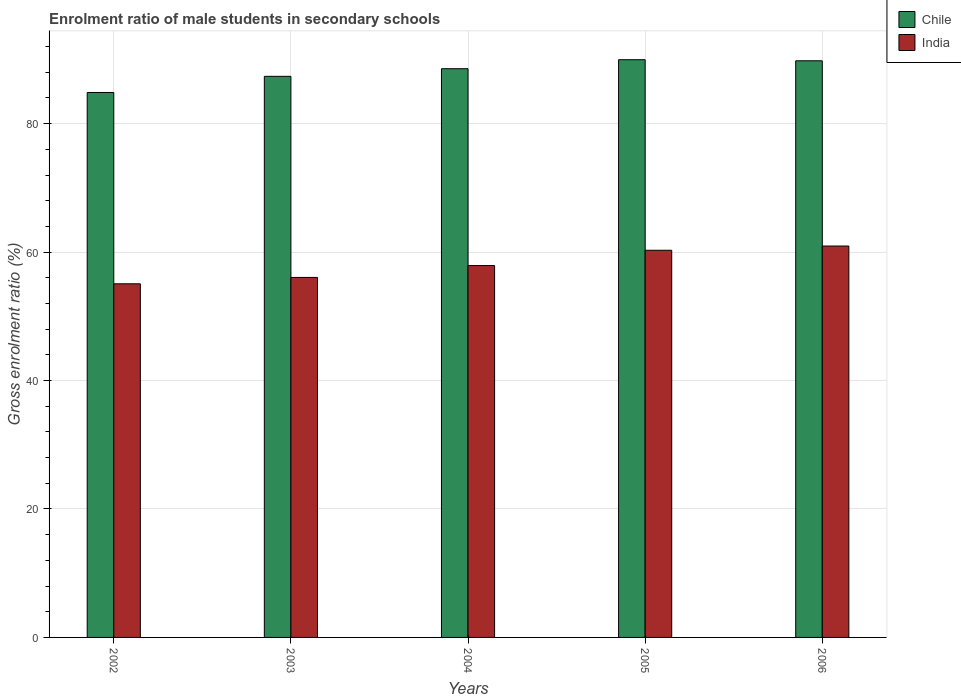How many different coloured bars are there?
Provide a succinct answer. 2. Are the number of bars on each tick of the X-axis equal?
Provide a succinct answer. Yes. How many bars are there on the 5th tick from the right?
Provide a short and direct response. 2. What is the label of the 1st group of bars from the left?
Your answer should be very brief. 2002. In how many cases, is the number of bars for a given year not equal to the number of legend labels?
Your answer should be very brief. 0. What is the enrolment ratio of male students in secondary schools in India in 2002?
Your answer should be very brief. 55.06. Across all years, what is the maximum enrolment ratio of male students in secondary schools in Chile?
Give a very brief answer. 89.95. Across all years, what is the minimum enrolment ratio of male students in secondary schools in India?
Your response must be concise. 55.06. What is the total enrolment ratio of male students in secondary schools in Chile in the graph?
Provide a short and direct response. 440.51. What is the difference between the enrolment ratio of male students in secondary schools in India in 2002 and that in 2003?
Your response must be concise. -0.99. What is the difference between the enrolment ratio of male students in secondary schools in Chile in 2003 and the enrolment ratio of male students in secondary schools in India in 2002?
Offer a terse response. 32.3. What is the average enrolment ratio of male students in secondary schools in Chile per year?
Ensure brevity in your answer.  88.1. In the year 2006, what is the difference between the enrolment ratio of male students in secondary schools in Chile and enrolment ratio of male students in secondary schools in India?
Make the answer very short. 28.84. In how many years, is the enrolment ratio of male students in secondary schools in India greater than 12 %?
Provide a succinct answer. 5. What is the ratio of the enrolment ratio of male students in secondary schools in India in 2003 to that in 2005?
Offer a very short reply. 0.93. Is the enrolment ratio of male students in secondary schools in Chile in 2002 less than that in 2003?
Keep it short and to the point. Yes. What is the difference between the highest and the second highest enrolment ratio of male students in secondary schools in Chile?
Make the answer very short. 0.17. What is the difference between the highest and the lowest enrolment ratio of male students in secondary schools in Chile?
Give a very brief answer. 5.1. In how many years, is the enrolment ratio of male students in secondary schools in India greater than the average enrolment ratio of male students in secondary schools in India taken over all years?
Offer a very short reply. 2. What does the 2nd bar from the right in 2002 represents?
Your response must be concise. Chile. What is the difference between two consecutive major ticks on the Y-axis?
Provide a succinct answer. 20. Does the graph contain any zero values?
Your response must be concise. No. Where does the legend appear in the graph?
Make the answer very short. Top right. How many legend labels are there?
Give a very brief answer. 2. How are the legend labels stacked?
Your answer should be very brief. Vertical. What is the title of the graph?
Your response must be concise. Enrolment ratio of male students in secondary schools. What is the label or title of the Y-axis?
Make the answer very short. Gross enrolment ratio (%). What is the Gross enrolment ratio (%) in Chile in 2002?
Offer a very short reply. 84.85. What is the Gross enrolment ratio (%) in India in 2002?
Provide a short and direct response. 55.06. What is the Gross enrolment ratio (%) of Chile in 2003?
Keep it short and to the point. 87.36. What is the Gross enrolment ratio (%) of India in 2003?
Your answer should be very brief. 56.05. What is the Gross enrolment ratio (%) of Chile in 2004?
Offer a very short reply. 88.55. What is the Gross enrolment ratio (%) in India in 2004?
Give a very brief answer. 57.9. What is the Gross enrolment ratio (%) of Chile in 2005?
Provide a short and direct response. 89.95. What is the Gross enrolment ratio (%) of India in 2005?
Your answer should be very brief. 60.28. What is the Gross enrolment ratio (%) of Chile in 2006?
Give a very brief answer. 89.79. What is the Gross enrolment ratio (%) in India in 2006?
Provide a short and direct response. 60.94. Across all years, what is the maximum Gross enrolment ratio (%) of Chile?
Your answer should be compact. 89.95. Across all years, what is the maximum Gross enrolment ratio (%) of India?
Provide a succinct answer. 60.94. Across all years, what is the minimum Gross enrolment ratio (%) of Chile?
Your answer should be very brief. 84.85. Across all years, what is the minimum Gross enrolment ratio (%) in India?
Ensure brevity in your answer.  55.06. What is the total Gross enrolment ratio (%) in Chile in the graph?
Your answer should be very brief. 440.51. What is the total Gross enrolment ratio (%) in India in the graph?
Make the answer very short. 290.24. What is the difference between the Gross enrolment ratio (%) of Chile in 2002 and that in 2003?
Make the answer very short. -2.51. What is the difference between the Gross enrolment ratio (%) in India in 2002 and that in 2003?
Provide a short and direct response. -0.99. What is the difference between the Gross enrolment ratio (%) of Chile in 2002 and that in 2004?
Provide a succinct answer. -3.7. What is the difference between the Gross enrolment ratio (%) of India in 2002 and that in 2004?
Your response must be concise. -2.84. What is the difference between the Gross enrolment ratio (%) of Chile in 2002 and that in 2005?
Provide a short and direct response. -5.1. What is the difference between the Gross enrolment ratio (%) of India in 2002 and that in 2005?
Make the answer very short. -5.22. What is the difference between the Gross enrolment ratio (%) in Chile in 2002 and that in 2006?
Offer a very short reply. -4.93. What is the difference between the Gross enrolment ratio (%) in India in 2002 and that in 2006?
Provide a short and direct response. -5.88. What is the difference between the Gross enrolment ratio (%) of Chile in 2003 and that in 2004?
Your response must be concise. -1.19. What is the difference between the Gross enrolment ratio (%) of India in 2003 and that in 2004?
Your answer should be compact. -1.85. What is the difference between the Gross enrolment ratio (%) in Chile in 2003 and that in 2005?
Ensure brevity in your answer.  -2.59. What is the difference between the Gross enrolment ratio (%) of India in 2003 and that in 2005?
Provide a succinct answer. -4.23. What is the difference between the Gross enrolment ratio (%) in Chile in 2003 and that in 2006?
Your answer should be very brief. -2.42. What is the difference between the Gross enrolment ratio (%) of India in 2003 and that in 2006?
Ensure brevity in your answer.  -4.89. What is the difference between the Gross enrolment ratio (%) in Chile in 2004 and that in 2005?
Keep it short and to the point. -1.4. What is the difference between the Gross enrolment ratio (%) of India in 2004 and that in 2005?
Give a very brief answer. -2.38. What is the difference between the Gross enrolment ratio (%) of Chile in 2004 and that in 2006?
Give a very brief answer. -1.23. What is the difference between the Gross enrolment ratio (%) of India in 2004 and that in 2006?
Ensure brevity in your answer.  -3.04. What is the difference between the Gross enrolment ratio (%) in Chile in 2005 and that in 2006?
Your answer should be compact. 0.17. What is the difference between the Gross enrolment ratio (%) in India in 2005 and that in 2006?
Give a very brief answer. -0.66. What is the difference between the Gross enrolment ratio (%) in Chile in 2002 and the Gross enrolment ratio (%) in India in 2003?
Your answer should be compact. 28.8. What is the difference between the Gross enrolment ratio (%) in Chile in 2002 and the Gross enrolment ratio (%) in India in 2004?
Provide a succinct answer. 26.95. What is the difference between the Gross enrolment ratio (%) of Chile in 2002 and the Gross enrolment ratio (%) of India in 2005?
Your response must be concise. 24.57. What is the difference between the Gross enrolment ratio (%) of Chile in 2002 and the Gross enrolment ratio (%) of India in 2006?
Offer a terse response. 23.91. What is the difference between the Gross enrolment ratio (%) in Chile in 2003 and the Gross enrolment ratio (%) in India in 2004?
Offer a very short reply. 29.46. What is the difference between the Gross enrolment ratio (%) in Chile in 2003 and the Gross enrolment ratio (%) in India in 2005?
Ensure brevity in your answer.  27.08. What is the difference between the Gross enrolment ratio (%) in Chile in 2003 and the Gross enrolment ratio (%) in India in 2006?
Provide a succinct answer. 26.42. What is the difference between the Gross enrolment ratio (%) of Chile in 2004 and the Gross enrolment ratio (%) of India in 2005?
Your response must be concise. 28.27. What is the difference between the Gross enrolment ratio (%) in Chile in 2004 and the Gross enrolment ratio (%) in India in 2006?
Your answer should be very brief. 27.61. What is the difference between the Gross enrolment ratio (%) of Chile in 2005 and the Gross enrolment ratio (%) of India in 2006?
Your answer should be very brief. 29.01. What is the average Gross enrolment ratio (%) of Chile per year?
Provide a short and direct response. 88.1. What is the average Gross enrolment ratio (%) in India per year?
Provide a succinct answer. 58.05. In the year 2002, what is the difference between the Gross enrolment ratio (%) of Chile and Gross enrolment ratio (%) of India?
Provide a succinct answer. 29.79. In the year 2003, what is the difference between the Gross enrolment ratio (%) in Chile and Gross enrolment ratio (%) in India?
Offer a terse response. 31.31. In the year 2004, what is the difference between the Gross enrolment ratio (%) in Chile and Gross enrolment ratio (%) in India?
Your response must be concise. 30.65. In the year 2005, what is the difference between the Gross enrolment ratio (%) of Chile and Gross enrolment ratio (%) of India?
Ensure brevity in your answer.  29.67. In the year 2006, what is the difference between the Gross enrolment ratio (%) of Chile and Gross enrolment ratio (%) of India?
Keep it short and to the point. 28.84. What is the ratio of the Gross enrolment ratio (%) in Chile in 2002 to that in 2003?
Give a very brief answer. 0.97. What is the ratio of the Gross enrolment ratio (%) in India in 2002 to that in 2003?
Your answer should be very brief. 0.98. What is the ratio of the Gross enrolment ratio (%) in Chile in 2002 to that in 2004?
Your answer should be very brief. 0.96. What is the ratio of the Gross enrolment ratio (%) in India in 2002 to that in 2004?
Provide a succinct answer. 0.95. What is the ratio of the Gross enrolment ratio (%) in Chile in 2002 to that in 2005?
Your answer should be compact. 0.94. What is the ratio of the Gross enrolment ratio (%) of India in 2002 to that in 2005?
Your answer should be compact. 0.91. What is the ratio of the Gross enrolment ratio (%) in Chile in 2002 to that in 2006?
Ensure brevity in your answer.  0.95. What is the ratio of the Gross enrolment ratio (%) in India in 2002 to that in 2006?
Offer a very short reply. 0.9. What is the ratio of the Gross enrolment ratio (%) of Chile in 2003 to that in 2004?
Your response must be concise. 0.99. What is the ratio of the Gross enrolment ratio (%) in India in 2003 to that in 2004?
Your response must be concise. 0.97. What is the ratio of the Gross enrolment ratio (%) of Chile in 2003 to that in 2005?
Provide a succinct answer. 0.97. What is the ratio of the Gross enrolment ratio (%) in India in 2003 to that in 2005?
Give a very brief answer. 0.93. What is the ratio of the Gross enrolment ratio (%) in Chile in 2003 to that in 2006?
Provide a short and direct response. 0.97. What is the ratio of the Gross enrolment ratio (%) of India in 2003 to that in 2006?
Ensure brevity in your answer.  0.92. What is the ratio of the Gross enrolment ratio (%) in Chile in 2004 to that in 2005?
Keep it short and to the point. 0.98. What is the ratio of the Gross enrolment ratio (%) in India in 2004 to that in 2005?
Make the answer very short. 0.96. What is the ratio of the Gross enrolment ratio (%) in Chile in 2004 to that in 2006?
Your response must be concise. 0.99. What is the ratio of the Gross enrolment ratio (%) of India in 2004 to that in 2006?
Offer a terse response. 0.95. What is the ratio of the Gross enrolment ratio (%) of Chile in 2005 to that in 2006?
Ensure brevity in your answer.  1. What is the difference between the highest and the second highest Gross enrolment ratio (%) of Chile?
Keep it short and to the point. 0.17. What is the difference between the highest and the second highest Gross enrolment ratio (%) in India?
Keep it short and to the point. 0.66. What is the difference between the highest and the lowest Gross enrolment ratio (%) in Chile?
Provide a short and direct response. 5.1. What is the difference between the highest and the lowest Gross enrolment ratio (%) in India?
Ensure brevity in your answer.  5.88. 